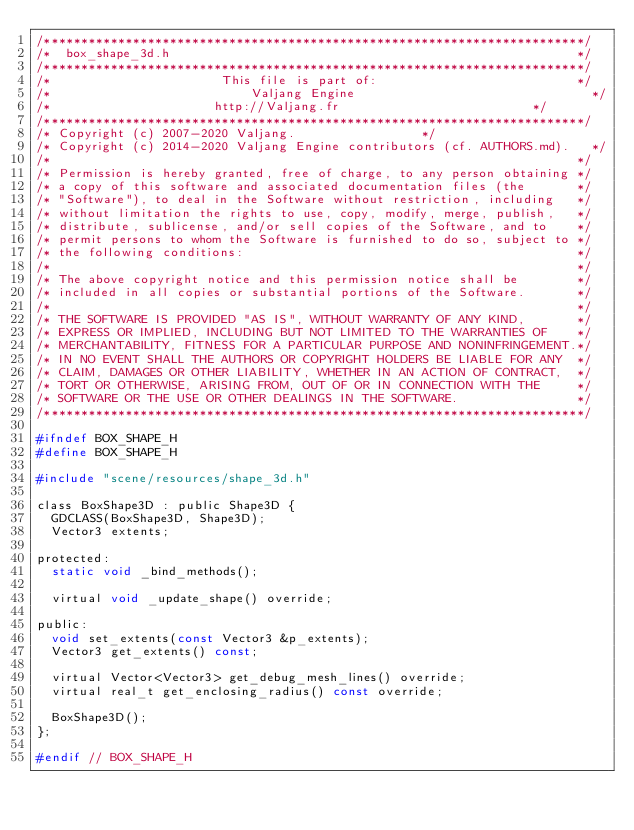<code> <loc_0><loc_0><loc_500><loc_500><_C_>/*************************************************************************/
/*  box_shape_3d.h                                                       */
/*************************************************************************/
/*                       This file is part of:                           */
/*                           Valjang Engine                                */
/*                      http://Valjang.fr                          */
/*************************************************************************/
/* Copyright (c) 2007-2020 Valjang.                 */
/* Copyright (c) 2014-2020 Valjang Engine contributors (cf. AUTHORS.md).   */
/*                                                                       */
/* Permission is hereby granted, free of charge, to any person obtaining */
/* a copy of this software and associated documentation files (the       */
/* "Software"), to deal in the Software without restriction, including   */
/* without limitation the rights to use, copy, modify, merge, publish,   */
/* distribute, sublicense, and/or sell copies of the Software, and to    */
/* permit persons to whom the Software is furnished to do so, subject to */
/* the following conditions:                                             */
/*                                                                       */
/* The above copyright notice and this permission notice shall be        */
/* included in all copies or substantial portions of the Software.       */
/*                                                                       */
/* THE SOFTWARE IS PROVIDED "AS IS", WITHOUT WARRANTY OF ANY KIND,       */
/* EXPRESS OR IMPLIED, INCLUDING BUT NOT LIMITED TO THE WARRANTIES OF    */
/* MERCHANTABILITY, FITNESS FOR A PARTICULAR PURPOSE AND NONINFRINGEMENT.*/
/* IN NO EVENT SHALL THE AUTHORS OR COPYRIGHT HOLDERS BE LIABLE FOR ANY  */
/* CLAIM, DAMAGES OR OTHER LIABILITY, WHETHER IN AN ACTION OF CONTRACT,  */
/* TORT OR OTHERWISE, ARISING FROM, OUT OF OR IN CONNECTION WITH THE     */
/* SOFTWARE OR THE USE OR OTHER DEALINGS IN THE SOFTWARE.                */
/*************************************************************************/

#ifndef BOX_SHAPE_H
#define BOX_SHAPE_H

#include "scene/resources/shape_3d.h"

class BoxShape3D : public Shape3D {
	GDCLASS(BoxShape3D, Shape3D);
	Vector3 extents;

protected:
	static void _bind_methods();

	virtual void _update_shape() override;

public:
	void set_extents(const Vector3 &p_extents);
	Vector3 get_extents() const;

	virtual Vector<Vector3> get_debug_mesh_lines() override;
	virtual real_t get_enclosing_radius() const override;

	BoxShape3D();
};

#endif // BOX_SHAPE_H
</code> 